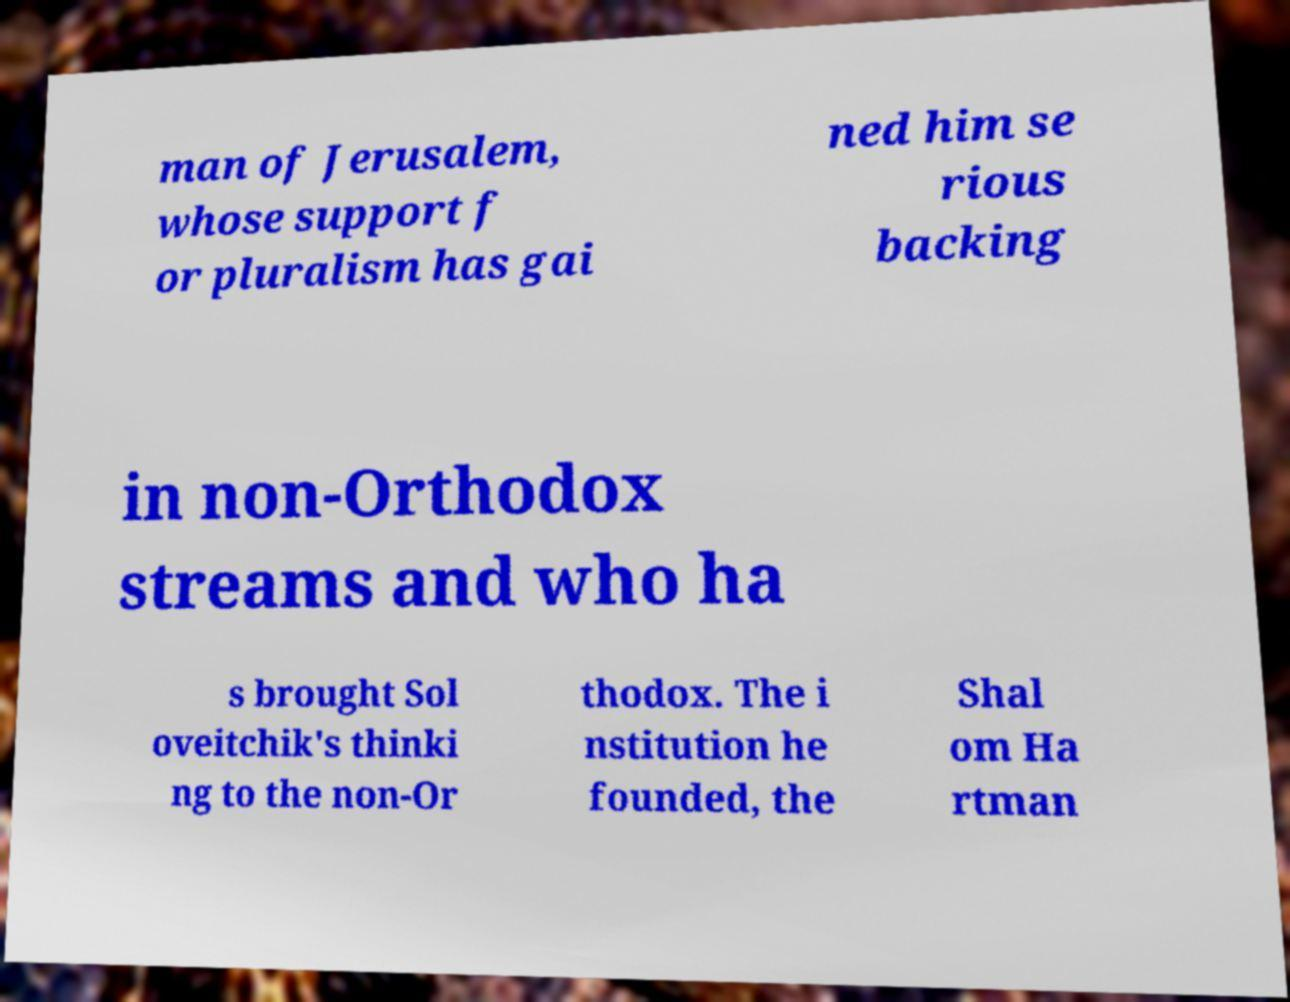There's text embedded in this image that I need extracted. Can you transcribe it verbatim? man of Jerusalem, whose support f or pluralism has gai ned him se rious backing in non-Orthodox streams and who ha s brought Sol oveitchik's thinki ng to the non-Or thodox. The i nstitution he founded, the Shal om Ha rtman 